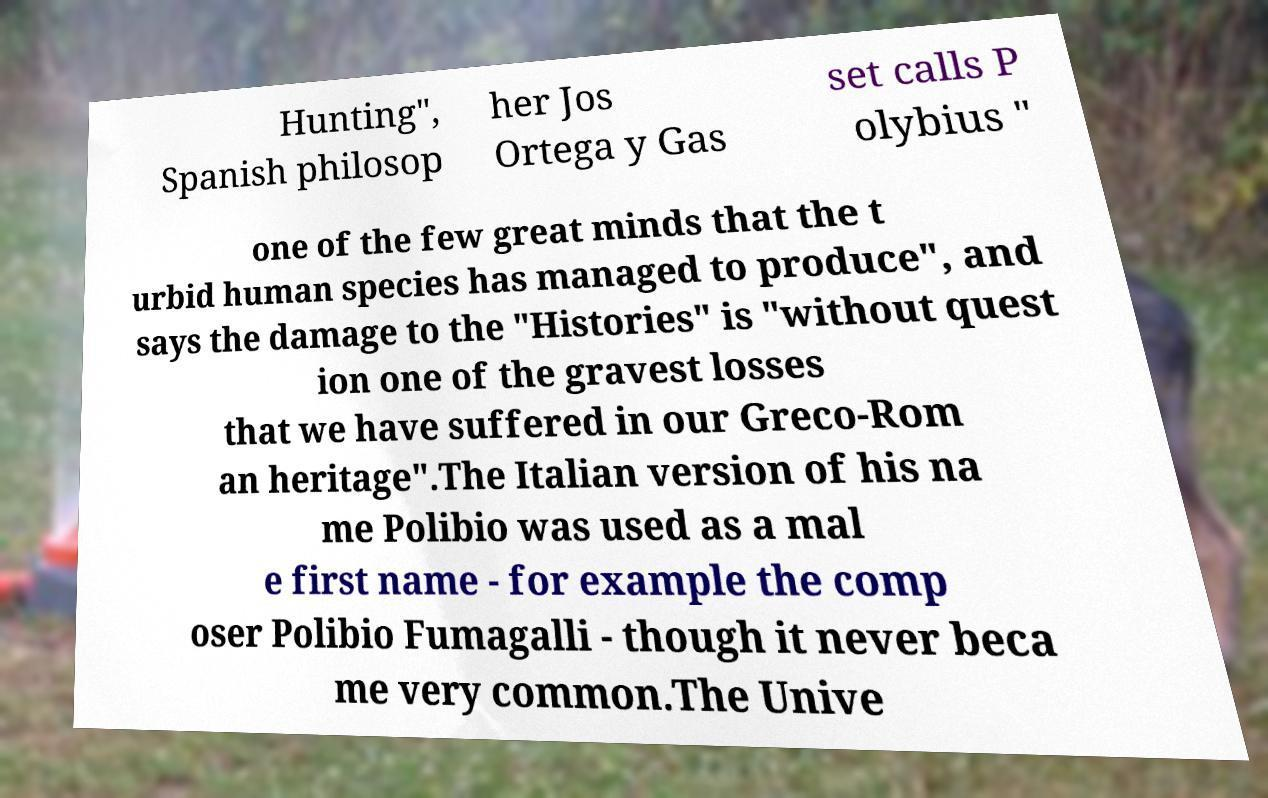For documentation purposes, I need the text within this image transcribed. Could you provide that? Hunting", Spanish philosop her Jos Ortega y Gas set calls P olybius " one of the few great minds that the t urbid human species has managed to produce", and says the damage to the "Histories" is "without quest ion one of the gravest losses that we have suffered in our Greco-Rom an heritage".The Italian version of his na me Polibio was used as a mal e first name - for example the comp oser Polibio Fumagalli - though it never beca me very common.The Unive 